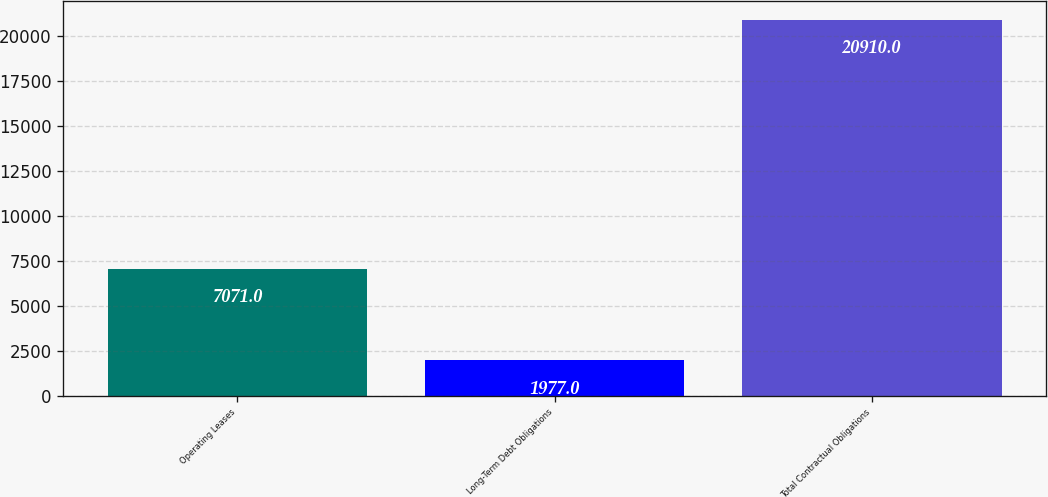Convert chart to OTSL. <chart><loc_0><loc_0><loc_500><loc_500><bar_chart><fcel>Operating Leases<fcel>Long-Term Debt Obligations<fcel>Total Contractual Obligations<nl><fcel>7071<fcel>1977<fcel>20910<nl></chart> 